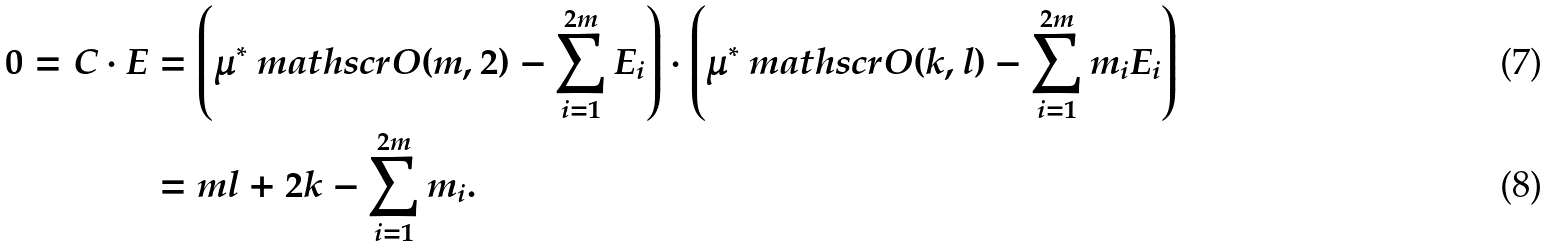Convert formula to latex. <formula><loc_0><loc_0><loc_500><loc_500>0 = C \cdot E & = \left ( \mu ^ { * } \ m a t h s c r O ( m , 2 ) - \sum _ { i = 1 } ^ { 2 m } E _ { i } \right ) \cdot \left ( \mu ^ { * } \ m a t h s c r O ( k , l ) - \sum _ { i = 1 } ^ { 2 m } m _ { i } E _ { i } \right ) \\ & = m l + 2 k - \sum _ { i = 1 } ^ { 2 m } m _ { i } .</formula> 